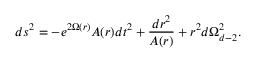Convert formula to latex. <formula><loc_0><loc_0><loc_500><loc_500>d s ^ { 2 } = - e ^ { 2 \Omega ( r ) } A ( r ) d t ^ { 2 } + \frac { d r ^ { 2 } } { A ( r ) } + r ^ { 2 } d \Omega _ { d - 2 } ^ { 2 } .</formula> 